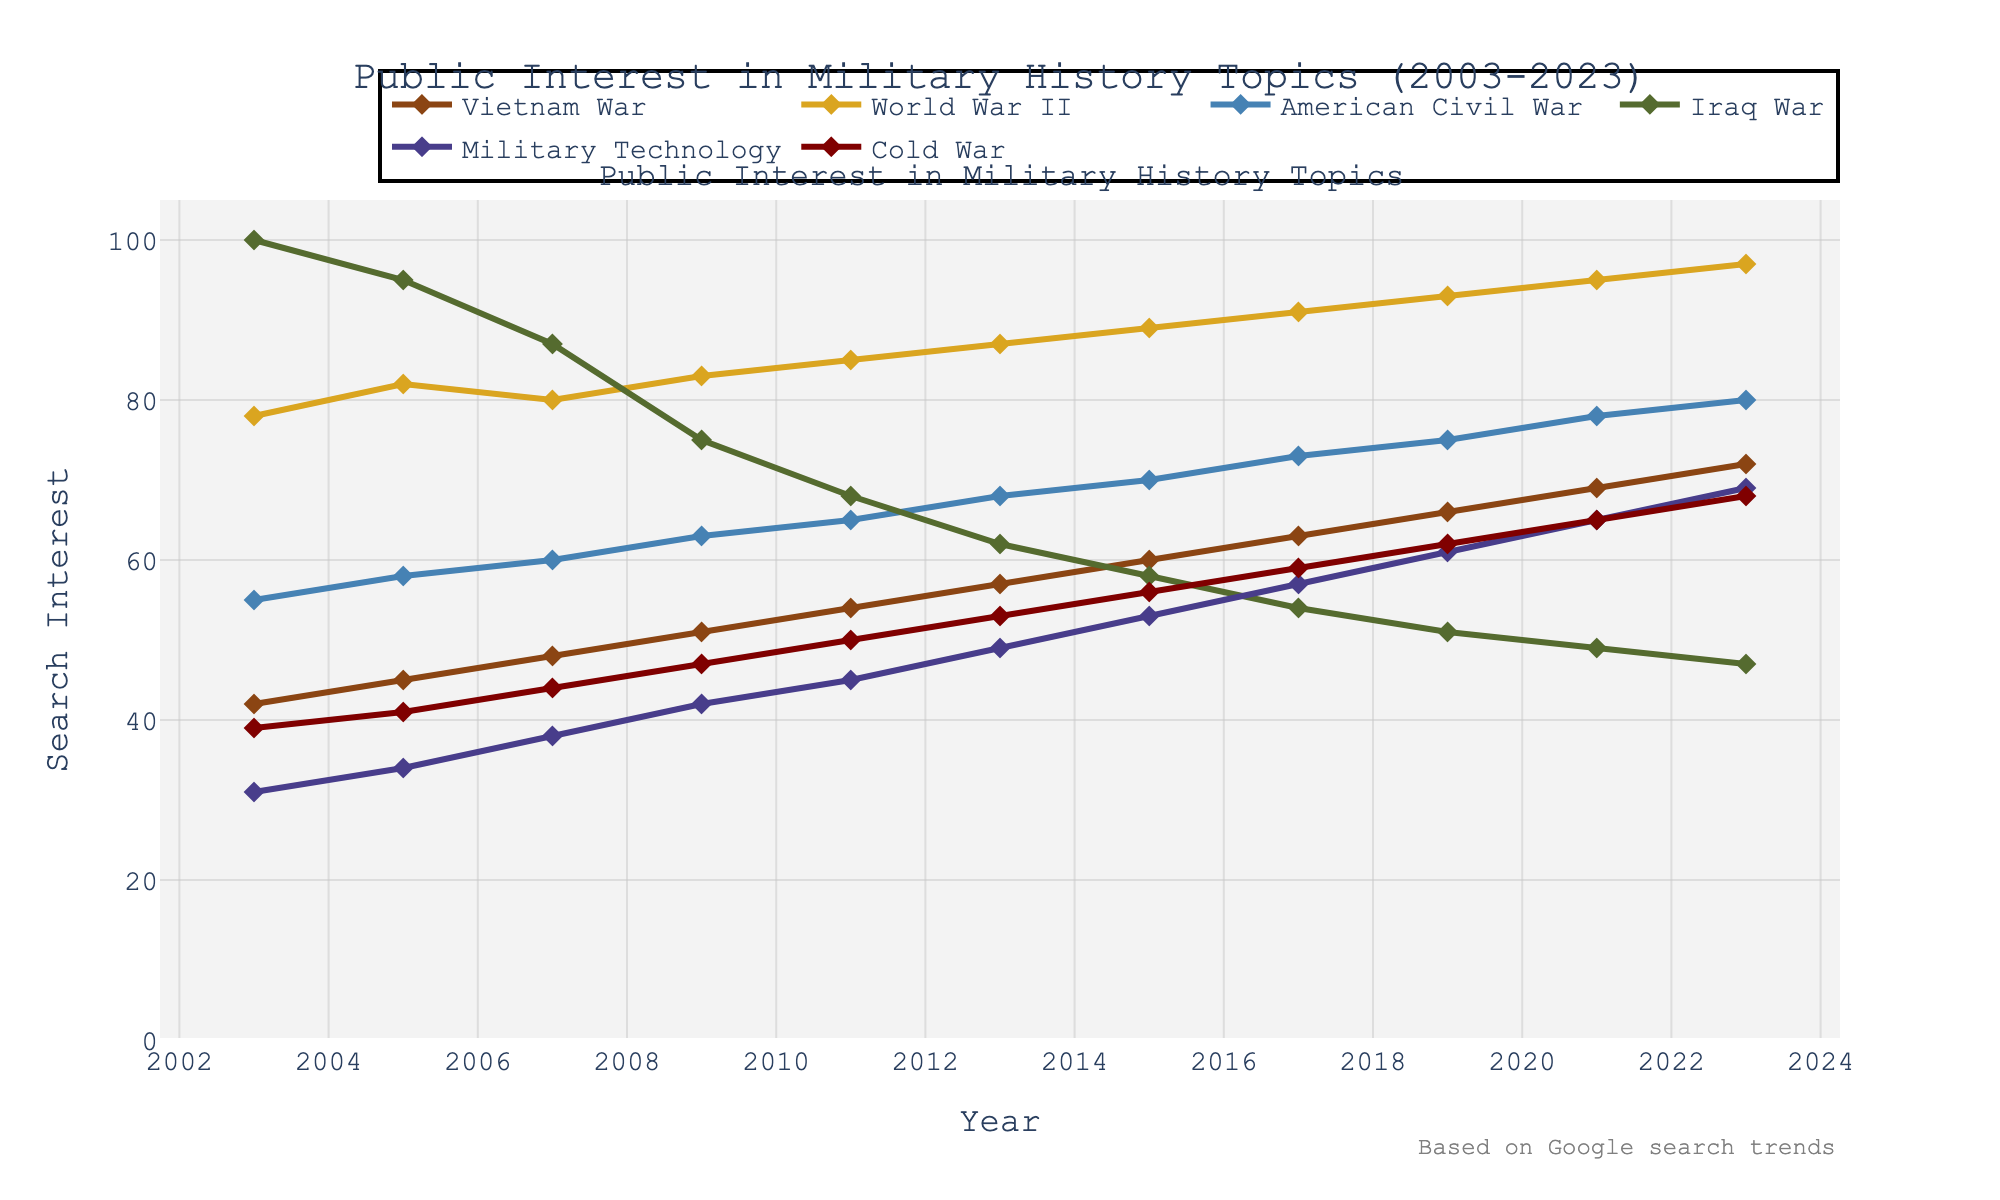What topic saw the highest search interest in 2003? Look at the data points for 2003 and identify the topic with the highest value. The Iraq War has the highest value of 100 in 2003.
Answer: Iraq War Which year did the Vietnam War surpass 50 in search interest? Check the values associated with the Vietnam War over the years. In 2009, the value for the Vietnam War reached 51.
Answer: 2009 How did the search interest in World War II and American Civil War compare in 2017? Find the values for both topics in 2017 and compare them. In 2017, World War II had a search interest of 91, while the American Civil War had a search interest of 73, so World War II had a higher search interest.
Answer: World War II had higher What's the average search interest for Military Technology between 2003 and 2023? Sum the values from 2003 to 2023 for Military Technology and divide by the number of years (11). Values: 31, 34, 38, 42, 45, 49, 53, 57, 61, 65, 69. Sum = (31 + 34 + 38 + 42 + 45 + 49 + 53 + 57 + 61 + 65 + 69) = 544. The average is 544/11 ≈ 49.45.
Answer: ≈49.45 How does the trend in search interest for the Cold War compare to that for the Iraq War over the two decades? Analyze the trend lines for both topics from 2003 to 2023. The Cold War shows a gradual increase from 39 to 68, while the Iraq War starts high at 100 in 2003 and decreases steadily to 47 in 2023.
Answer: Cold War increase, Iraq War decrease In which year does Military Technology show the greatest increase in search interest? Look for the year-over-year differences in search interest values for Military Technology and identify the largest change. From 2009 to 2011, the value increased from 42 to 45, which is the greatest increase of 3 points.
Answer: 2009 to 2011 Which topic shows the most consistent upward trend from 2003 to 2023? Compare the visual upward trends of each topic. The Vietnam War shows a consistent rise from 42 in 2003 to 72 in 2023.
Answer: Vietnam War What is the total change in search interest for the American Civil War between 2003 and 2023? Subtract the value in 2003 from the value in 2023 for the American Civil War. Values: 80 (2023) - 55 (2003) = 25.
Answer: 25 How did the search interest of World War II change from 2009 to 2011? Compare the values in 2009 and 2011 for World War II. In 2009 it was 83, in 2011 it was 85; the change is +2.
Answer: +2 